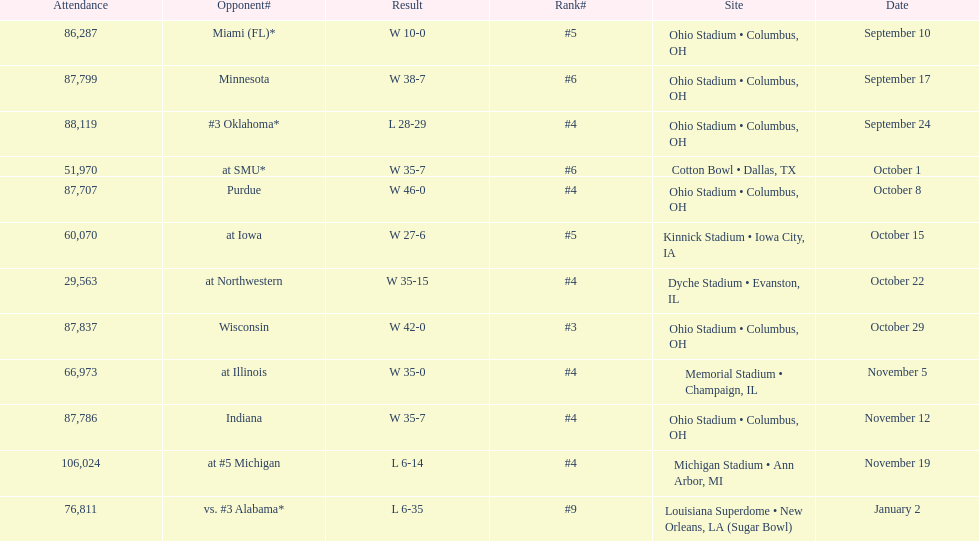How many dates are on the chart 12. 